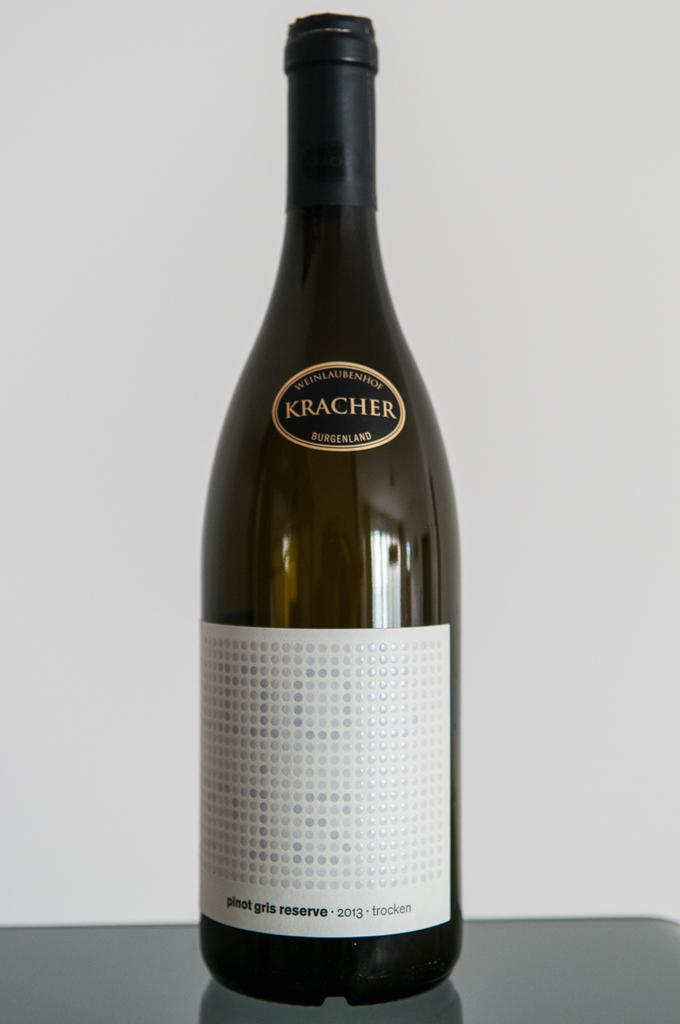<image>
Render a clear and concise summary of the photo. A Kracher wine bottle shows a white label. 